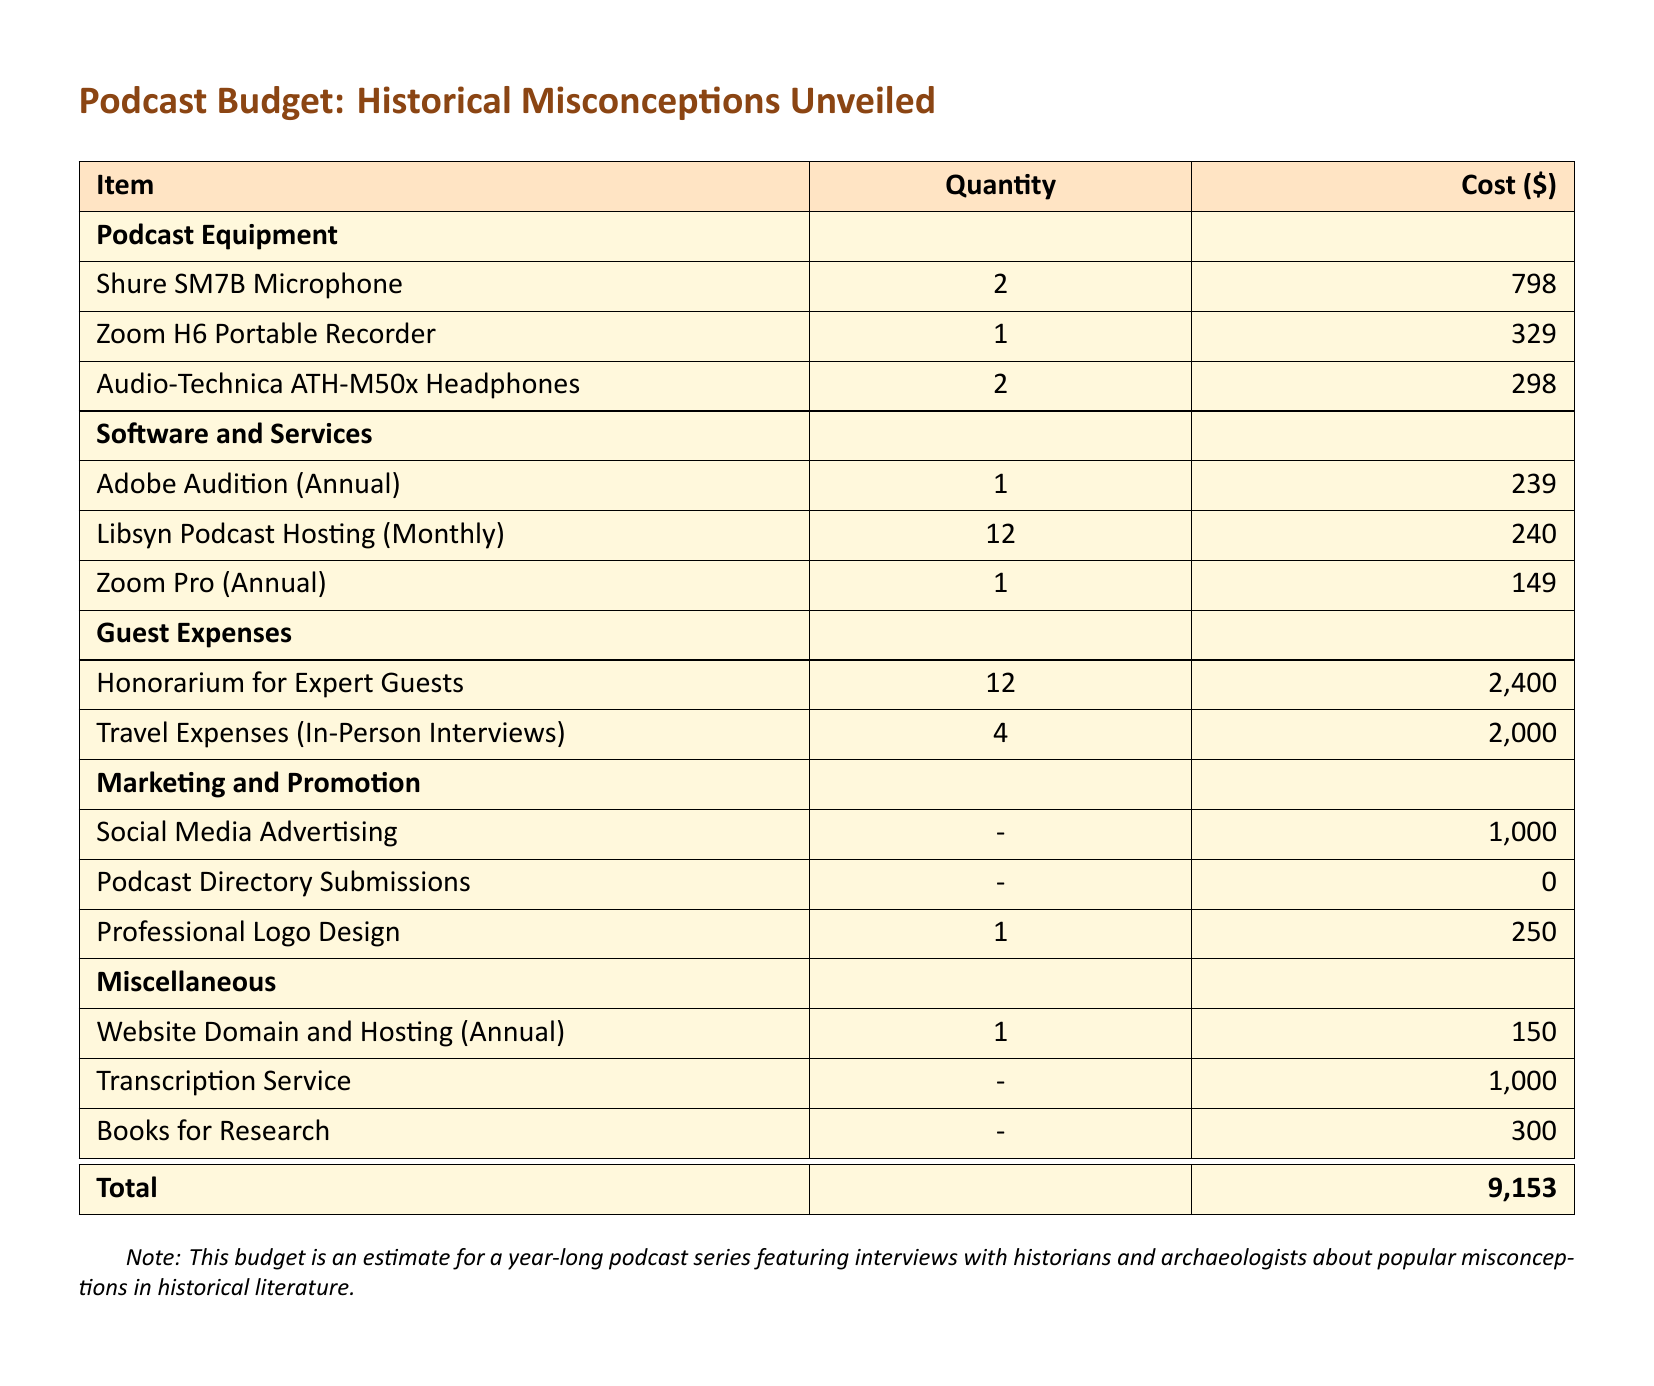What is the total cost of the podcast? The total cost is stated at the bottom of the budget table, summing all individual expenses.
Answer: 9,153 How many microphones are included in the budget? The budget lists the Shure SM7B Microphone and specifies the quantity required.
Answer: 2 What is the cost of the Zoom H6 Portable Recorder? The document shows the price for the Zoom H6 Portable Recorder in the equipment section.
Answer: 329 How many guest experts are budgeted for honorarium payments? The budget allocates funds for honorarium payments to a specific number of expert guests indicated in the guest expenses section.
Answer: 12 What is the annual cost for Adobe Audition? The budget specifies the cost of Adobe Audition for the year under software and services.
Answer: 239 What type of expenses are included in the marketing and promotion section? The document outlines multiple items covered in that section, highlighting various specific spending aspects.
Answer: Social Media Advertising, Podcast Directory Submissions, Professional Logo Design What is the estimated cost for transcription service? The budget provides a specific figure allocated for the transcription service in the miscellaneous section.
Answer: 1,000 How many travel expenses for in-person interviews are listed? The document provides a clear count of the number of in-person interviews accounted for within the travel expenses.
Answer: 4 What is the cost allocated for books for research? The budget outlines the funding designated for acquiring books related to research in the miscellaneous category.
Answer: 300 